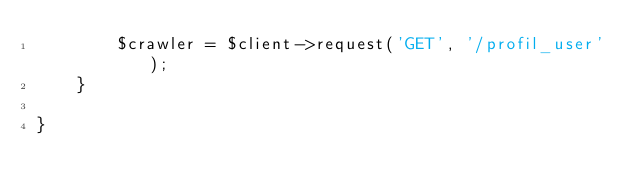Convert code to text. <code><loc_0><loc_0><loc_500><loc_500><_PHP_>        $crawler = $client->request('GET', '/profil_user');
    }

}
</code> 